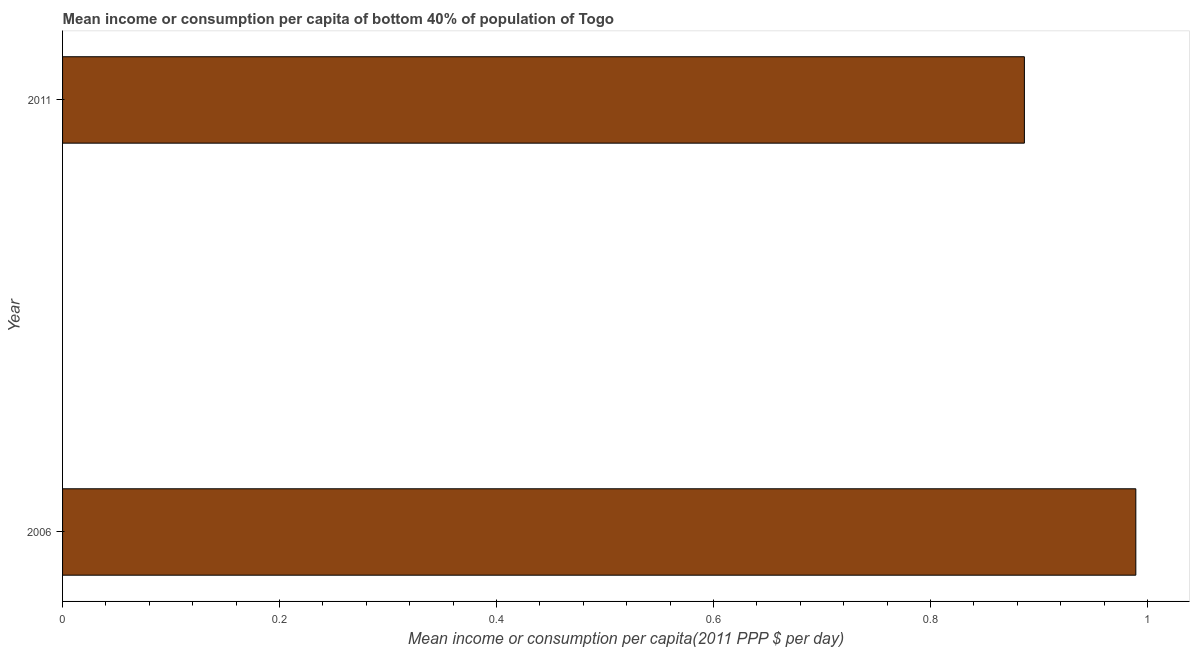What is the title of the graph?
Provide a succinct answer. Mean income or consumption per capita of bottom 40% of population of Togo. What is the label or title of the X-axis?
Ensure brevity in your answer.  Mean income or consumption per capita(2011 PPP $ per day). What is the label or title of the Y-axis?
Give a very brief answer. Year. What is the mean income or consumption in 2006?
Provide a succinct answer. 0.99. Across all years, what is the maximum mean income or consumption?
Keep it short and to the point. 0.99. Across all years, what is the minimum mean income or consumption?
Offer a terse response. 0.89. In which year was the mean income or consumption maximum?
Offer a very short reply. 2006. In which year was the mean income or consumption minimum?
Your answer should be compact. 2011. What is the sum of the mean income or consumption?
Offer a very short reply. 1.88. What is the difference between the mean income or consumption in 2006 and 2011?
Ensure brevity in your answer.  0.1. What is the average mean income or consumption per year?
Your response must be concise. 0.94. What is the median mean income or consumption?
Ensure brevity in your answer.  0.94. What is the ratio of the mean income or consumption in 2006 to that in 2011?
Make the answer very short. 1.12. In how many years, is the mean income or consumption greater than the average mean income or consumption taken over all years?
Provide a succinct answer. 1. Are all the bars in the graph horizontal?
Your response must be concise. Yes. What is the difference between two consecutive major ticks on the X-axis?
Give a very brief answer. 0.2. Are the values on the major ticks of X-axis written in scientific E-notation?
Your response must be concise. No. What is the Mean income or consumption per capita(2011 PPP $ per day) in 2006?
Your answer should be compact. 0.99. What is the Mean income or consumption per capita(2011 PPP $ per day) of 2011?
Your answer should be compact. 0.89. What is the difference between the Mean income or consumption per capita(2011 PPP $ per day) in 2006 and 2011?
Offer a terse response. 0.1. What is the ratio of the Mean income or consumption per capita(2011 PPP $ per day) in 2006 to that in 2011?
Keep it short and to the point. 1.12. 